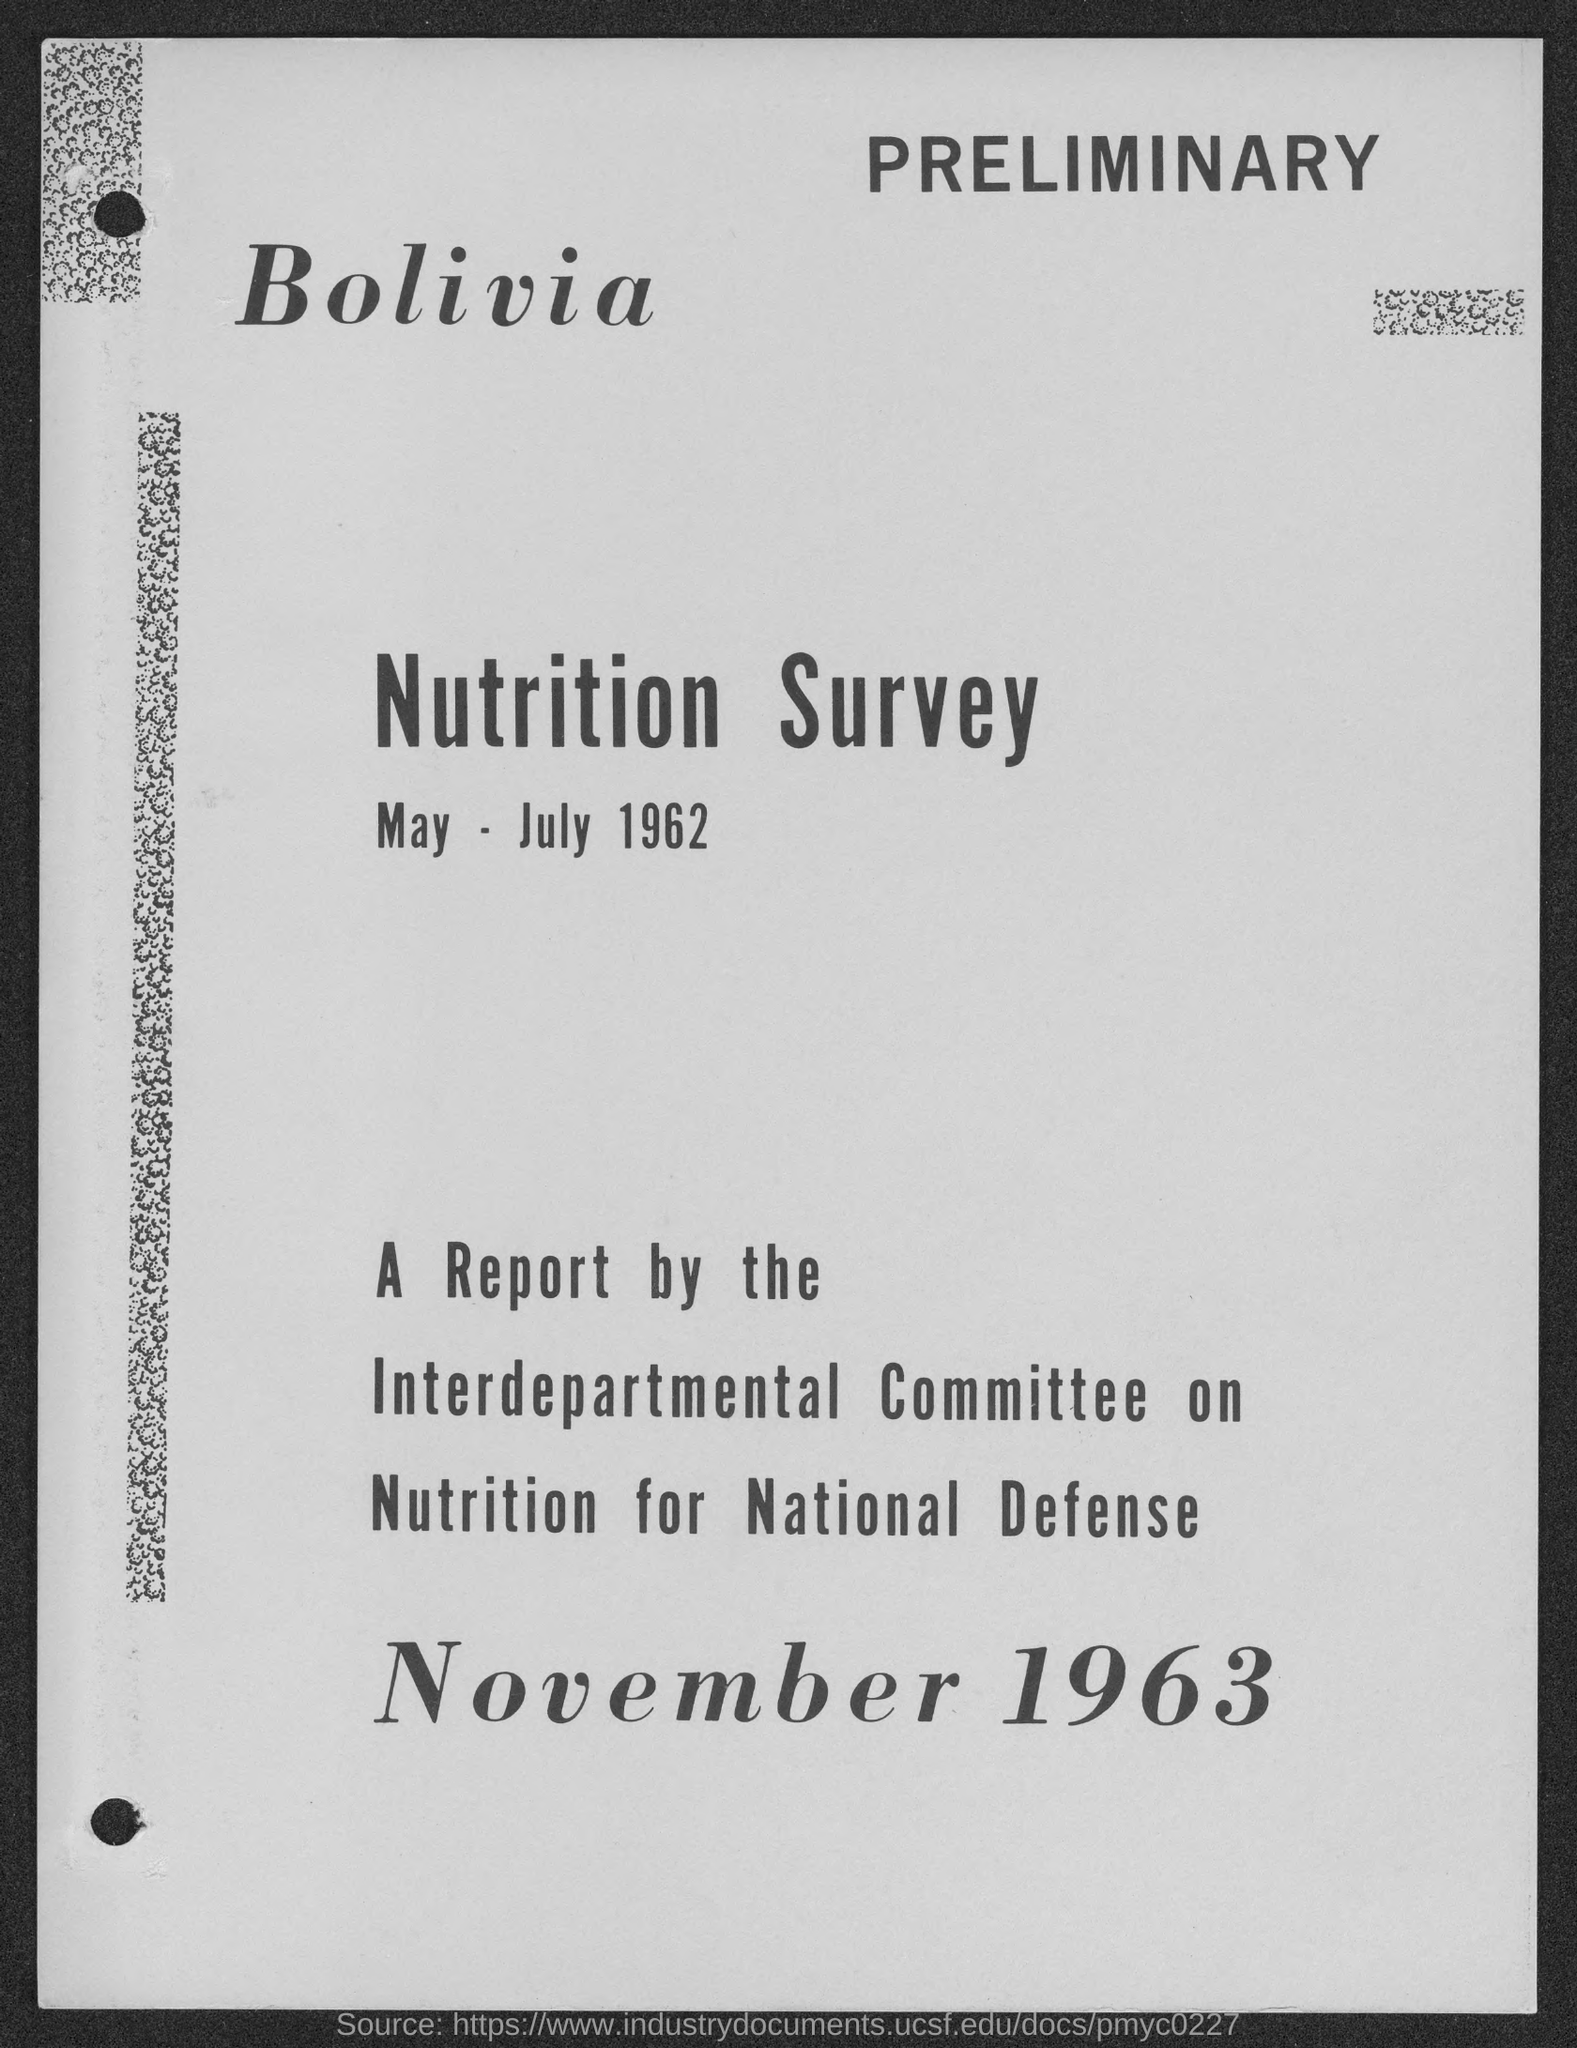What is the date mentioned in the top of the document ?
Offer a terse response. May - July 1962. What is the Date mentioned in the bottom of the document ?
Keep it short and to the point. November 1963. 